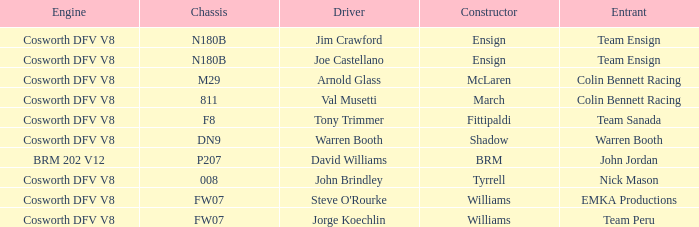Who assembled warren booth's vehicle with the cosworth dfv v8 engine? Shadow. 